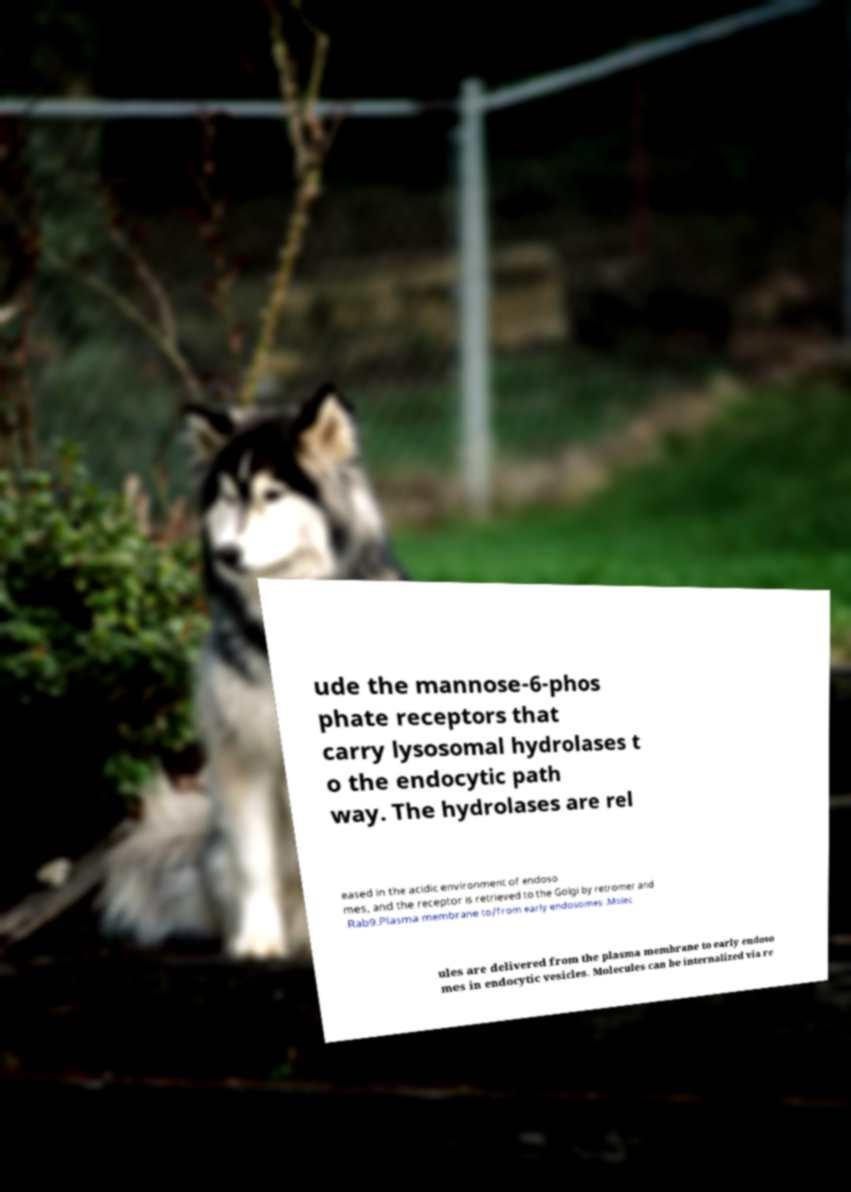Could you assist in decoding the text presented in this image and type it out clearly? ude the mannose-6-phos phate receptors that carry lysosomal hydrolases t o the endocytic path way. The hydrolases are rel eased in the acidic environment of endoso mes, and the receptor is retrieved to the Golgi by retromer and Rab9.Plasma membrane to/from early endosomes .Molec ules are delivered from the plasma membrane to early endoso mes in endocytic vesicles. Molecules can be internalized via re 